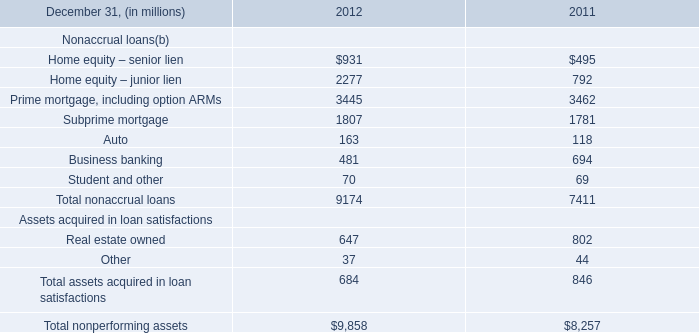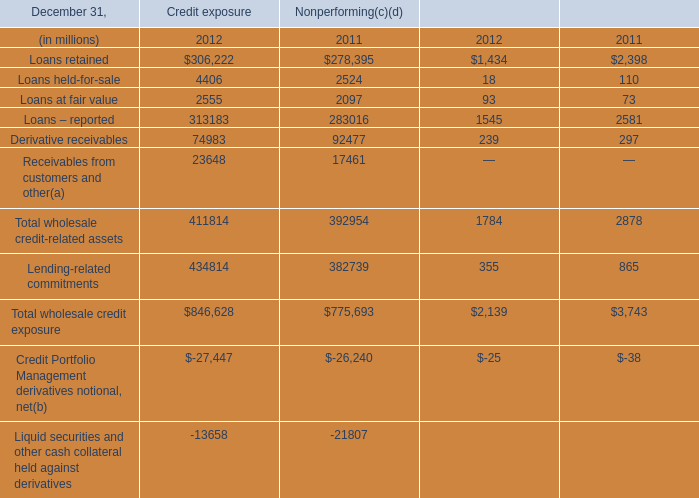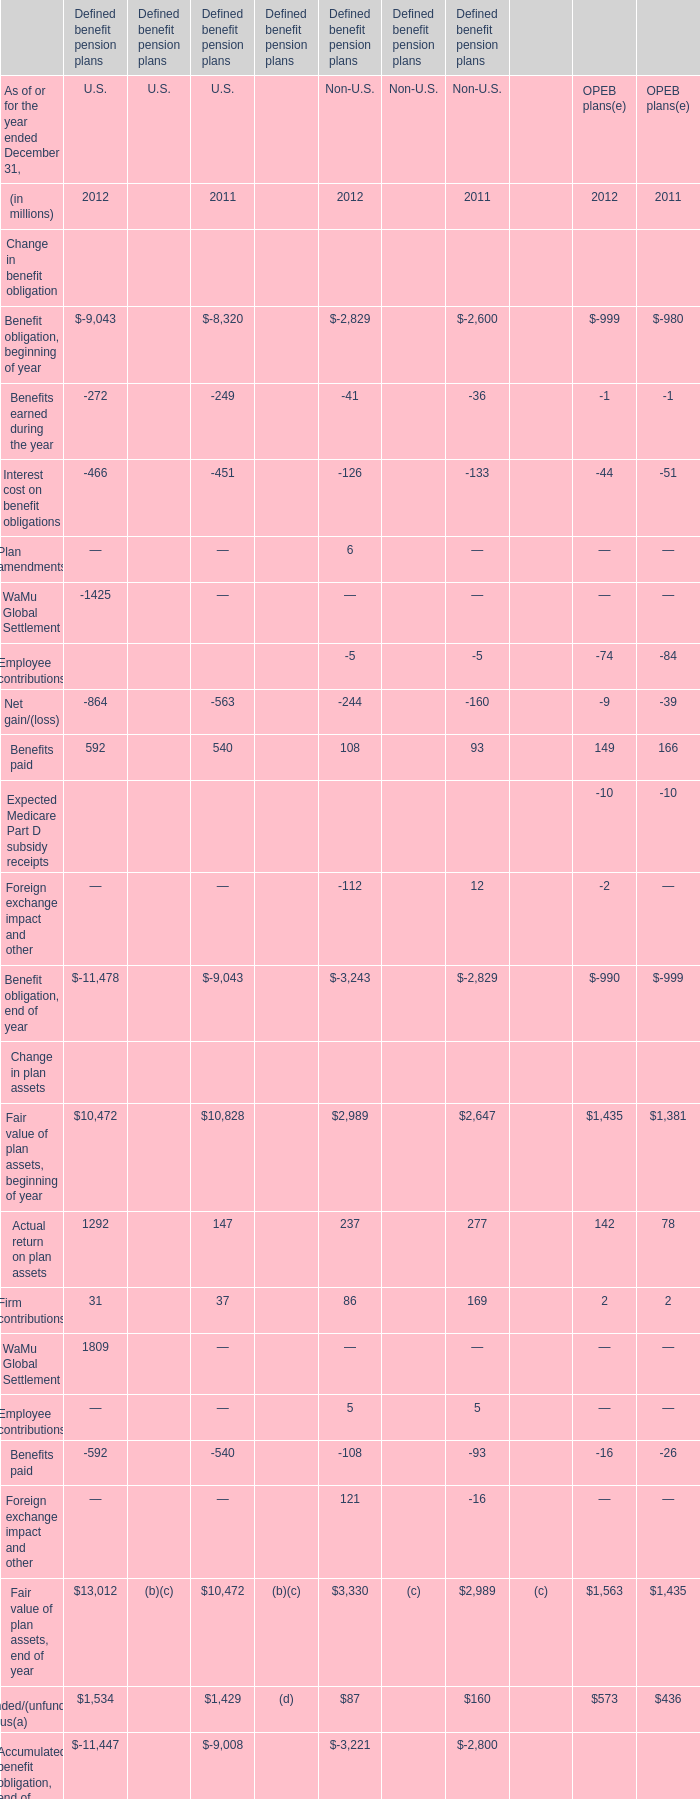what's the total amount of Loans – reported of Nonperforming 2011, Subprime mortgage of 2012, and Benefit obligation, end of year of Defined benefit pension plans U.S. 2011 ? 
Computations: ((283016.0 + 1807.0) + 9043.0)
Answer: 293866.0. 